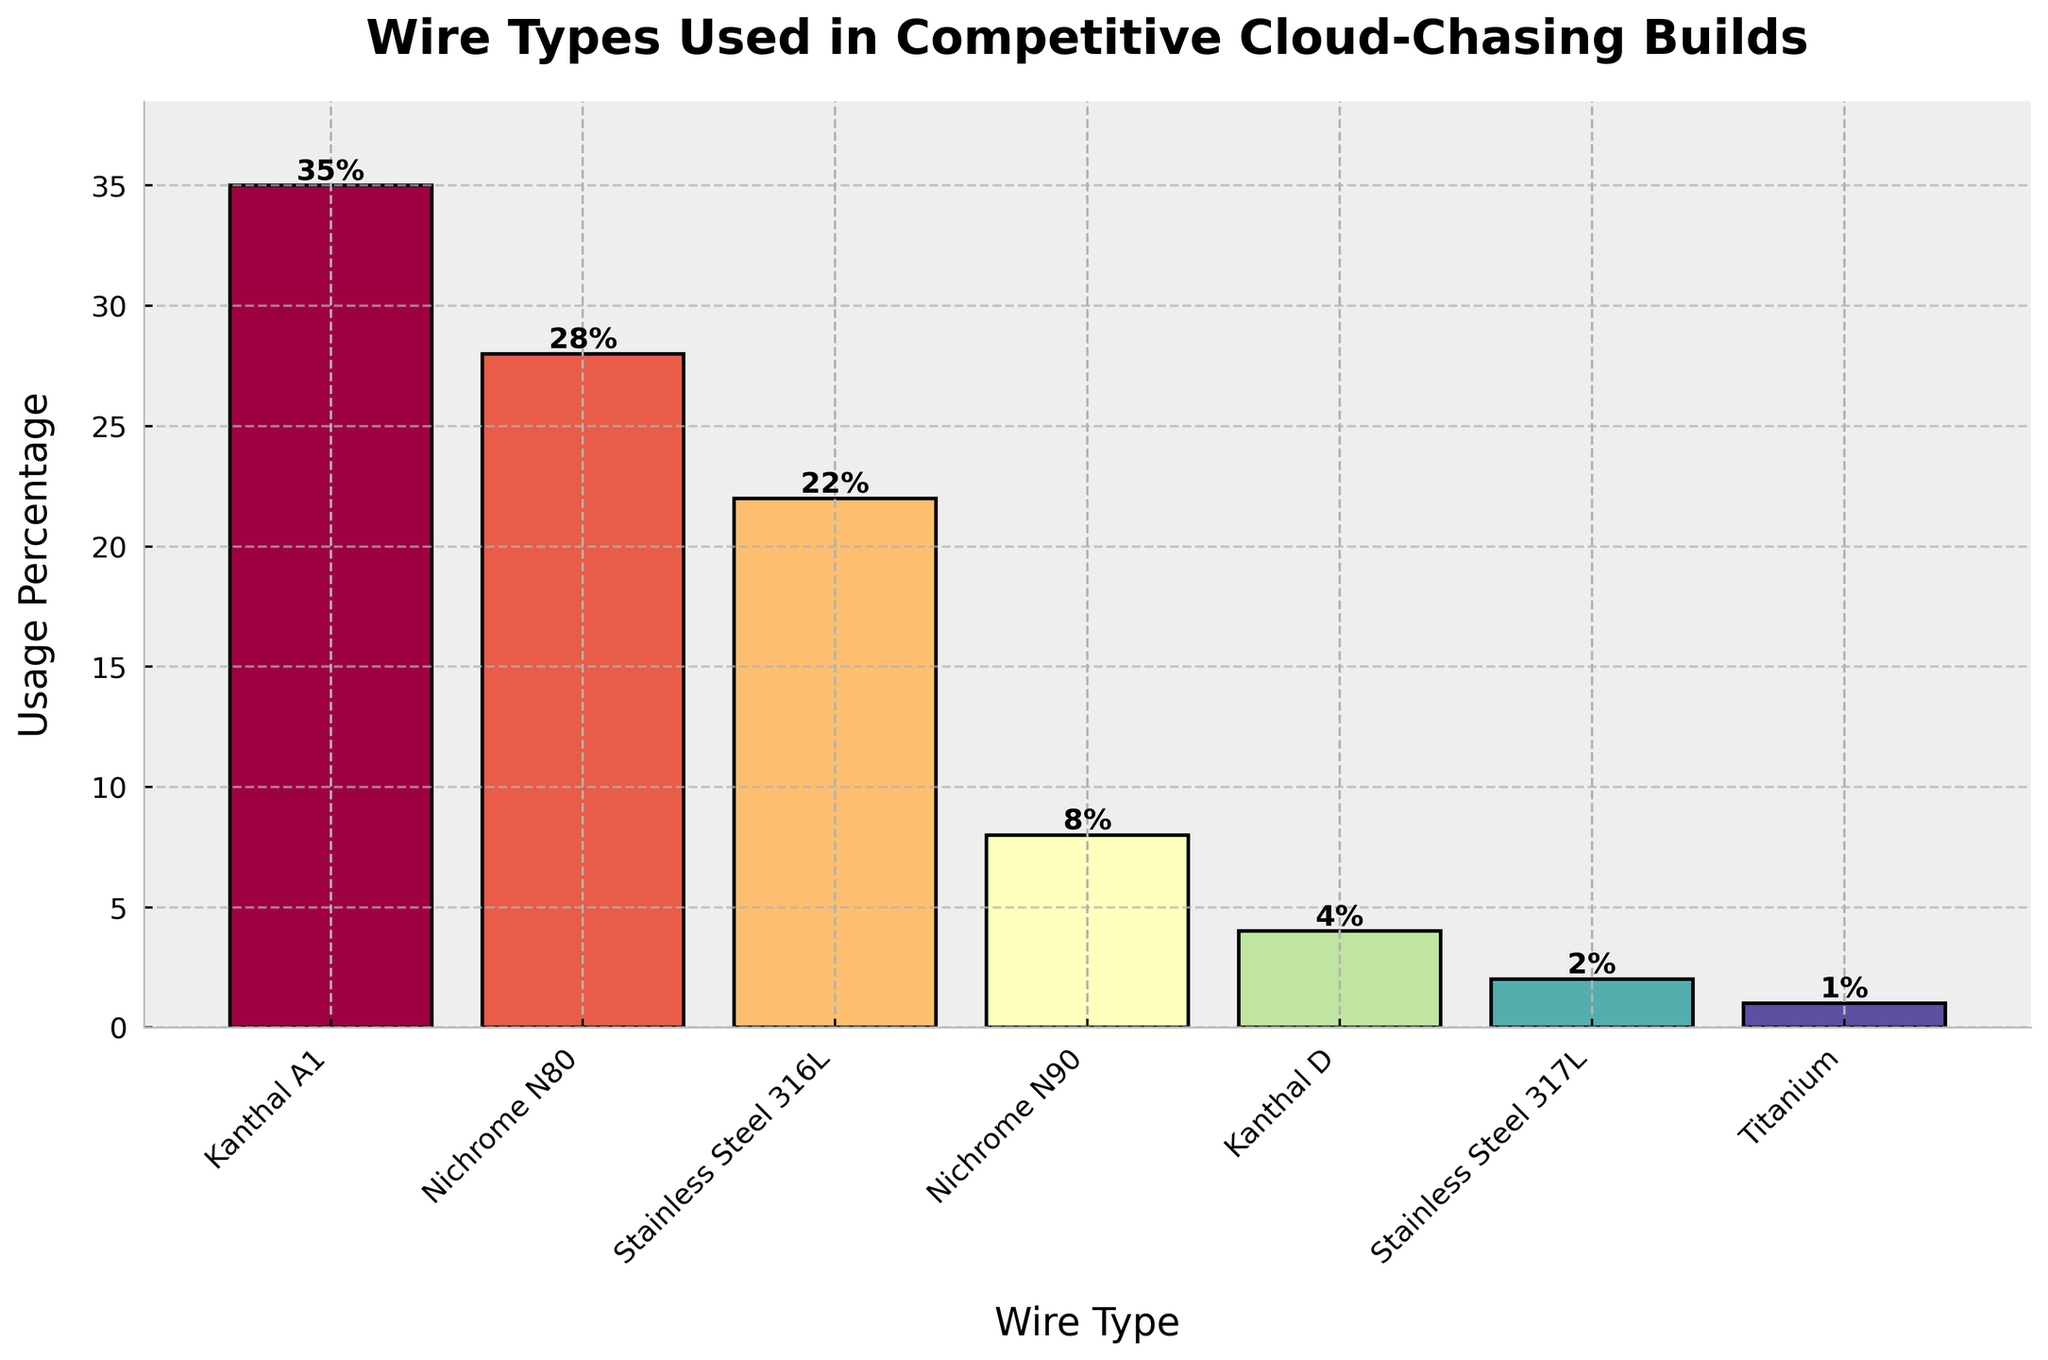What's the most frequently used wire type in competitive cloud-chasing builds? The bar chart shows "Kanthal A1" as the wire type with the highest bar, which indicates it's the most frequently used wire type.
Answer: Kanthal A1 Which wire type is used more frequently, Nichrome N80 or Stainless Steel 316L? By observing the height of the bars, Nichrome N80 has a taller bar (28%) compared to Stainless Steel 316L (22%).
Answer: Nichrome N80 What is the combined usage percentage of Stainless Steel 317L and Titanium? Look at the individual percentages for Stainless Steel 317L (2%) and Titanium (1%), then add them together: 2% + 1% = 3%.
Answer: 3% Which wire type has the smallest usage percentage, and what is that percentage? The smallest bar on the chart corresponds to Titanium with a usage percentage of 1%.
Answer: Titanium, 1% How much more popular is Kanthal A1 compared to Nichrome N90 in competitive cloud-chasing builds? The usage percentage of Kanthal A1 is 35% and Nichrome N90 is 8%. Subtracting these values gives: 35% - 8% = 27%.
Answer: 27% Rank the top three wire types in terms of usage percentage. By observing the heights of the bars, Kanthal A1 (35%), Nichrome N80 (28%), and Stainless Steel 316L (22%) are the top three.
Answer: Kanthal A1, Nichrome N80, Stainless Steel 316L What is the difference in usage percentage between the most and least popular wire types? The most popular wire type is Kanthal A1 at 35%, and the least popular is Titanium at 1%. Subtracting these values gives: 35% - 1% = 34%.
Answer: 34% What is the average usage percentage of all the wire types listed? Sum the usage percentages of all wire types: 35% + 28% + 22% + 8% + 4% + 2% + 1% = 100%. Divide by the number of wire types (7): 100% / 7 ≈ 14.29%.
Answer: 14.29% If you combine the usage percentages of all types of Kanthal, what percentage do you get? Add the percentages of Kanthal A1 (35%) and Kanthal D (4%): 35% + 4% = 39%.
Answer: 39% Which two wire types have the closest usage percentages? By looking at the chart, Stainless Steel 316L (22%) and Nichrome N90 (8%) have the closest usage percentages with a difference of only 2%.
Answer: Kanthal D and Stainless Steel 317L 